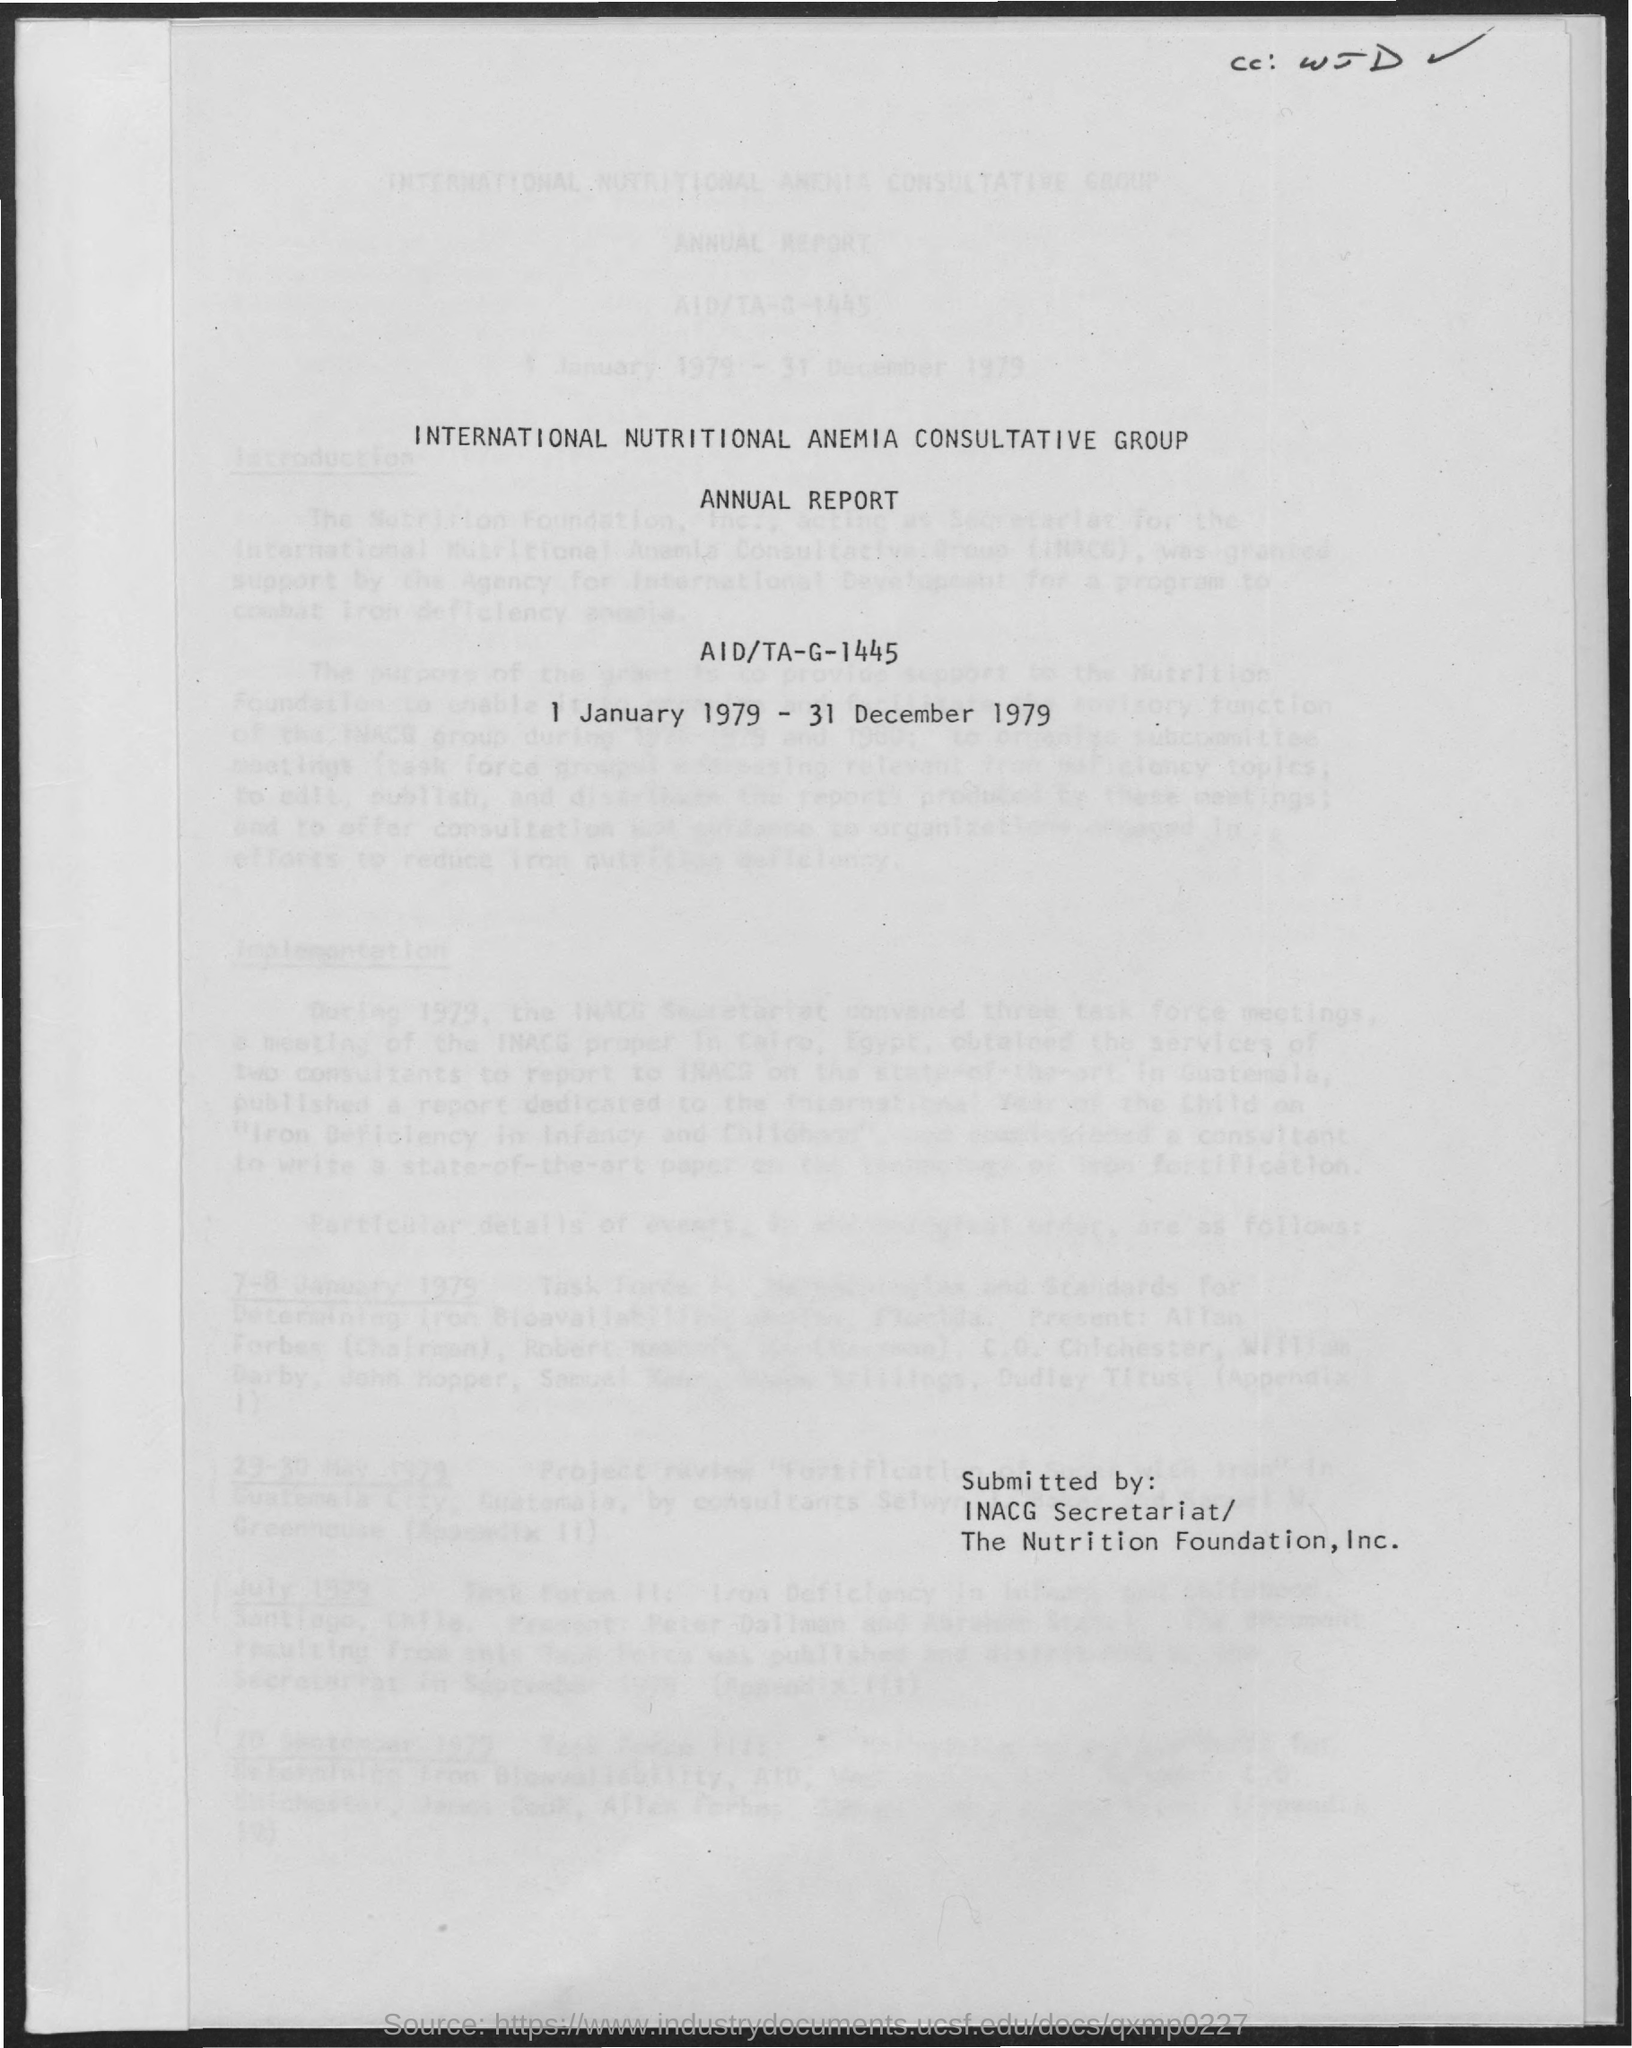What does inacg stand for?
Offer a terse response. International nutritional anemia consultative group. To which period does this annual report belong to?
Offer a terse response. 1 January 1979- 31 December 1979. 